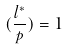<formula> <loc_0><loc_0><loc_500><loc_500>( \frac { l ^ { * } } { p } ) = 1</formula> 